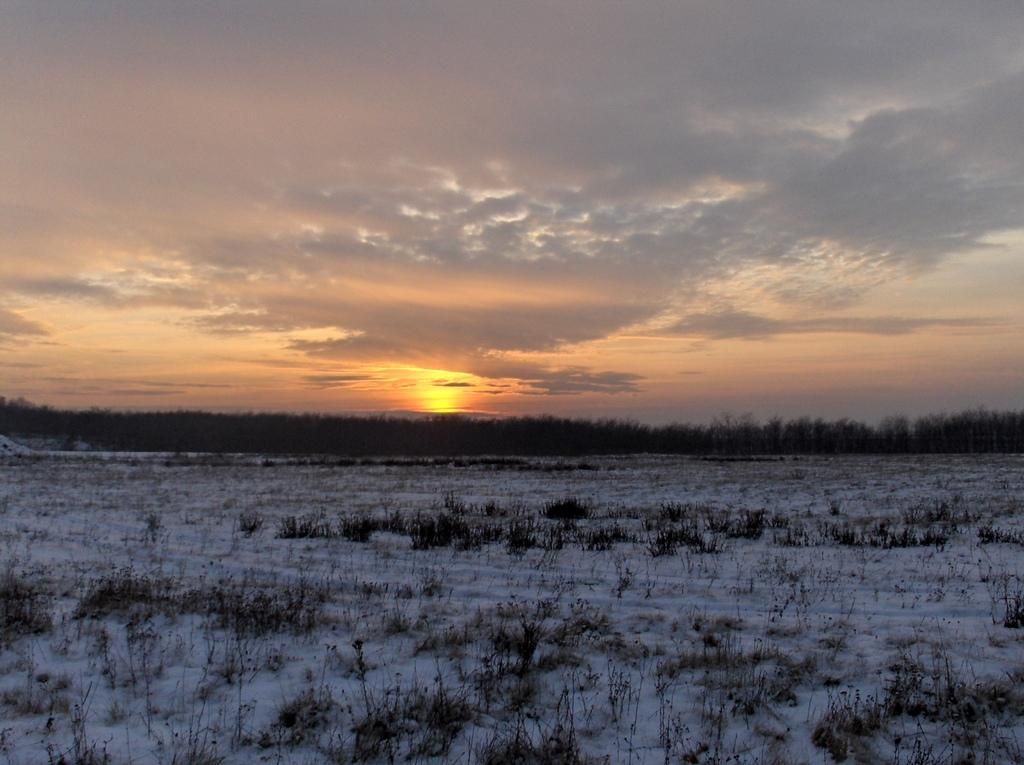What celestial body is visible in the image? There is a sun in the image. What is the background of the image? There is sky visible in the image. What type of vegetation is present in the image? There are trees in the image. What is the state of the ice in the image? The ice is present in the image. What type of stone is being used to stop the sun in the image? There is no stone or attempt to stop the sun in the image; the sun is simply visible in the sky. 